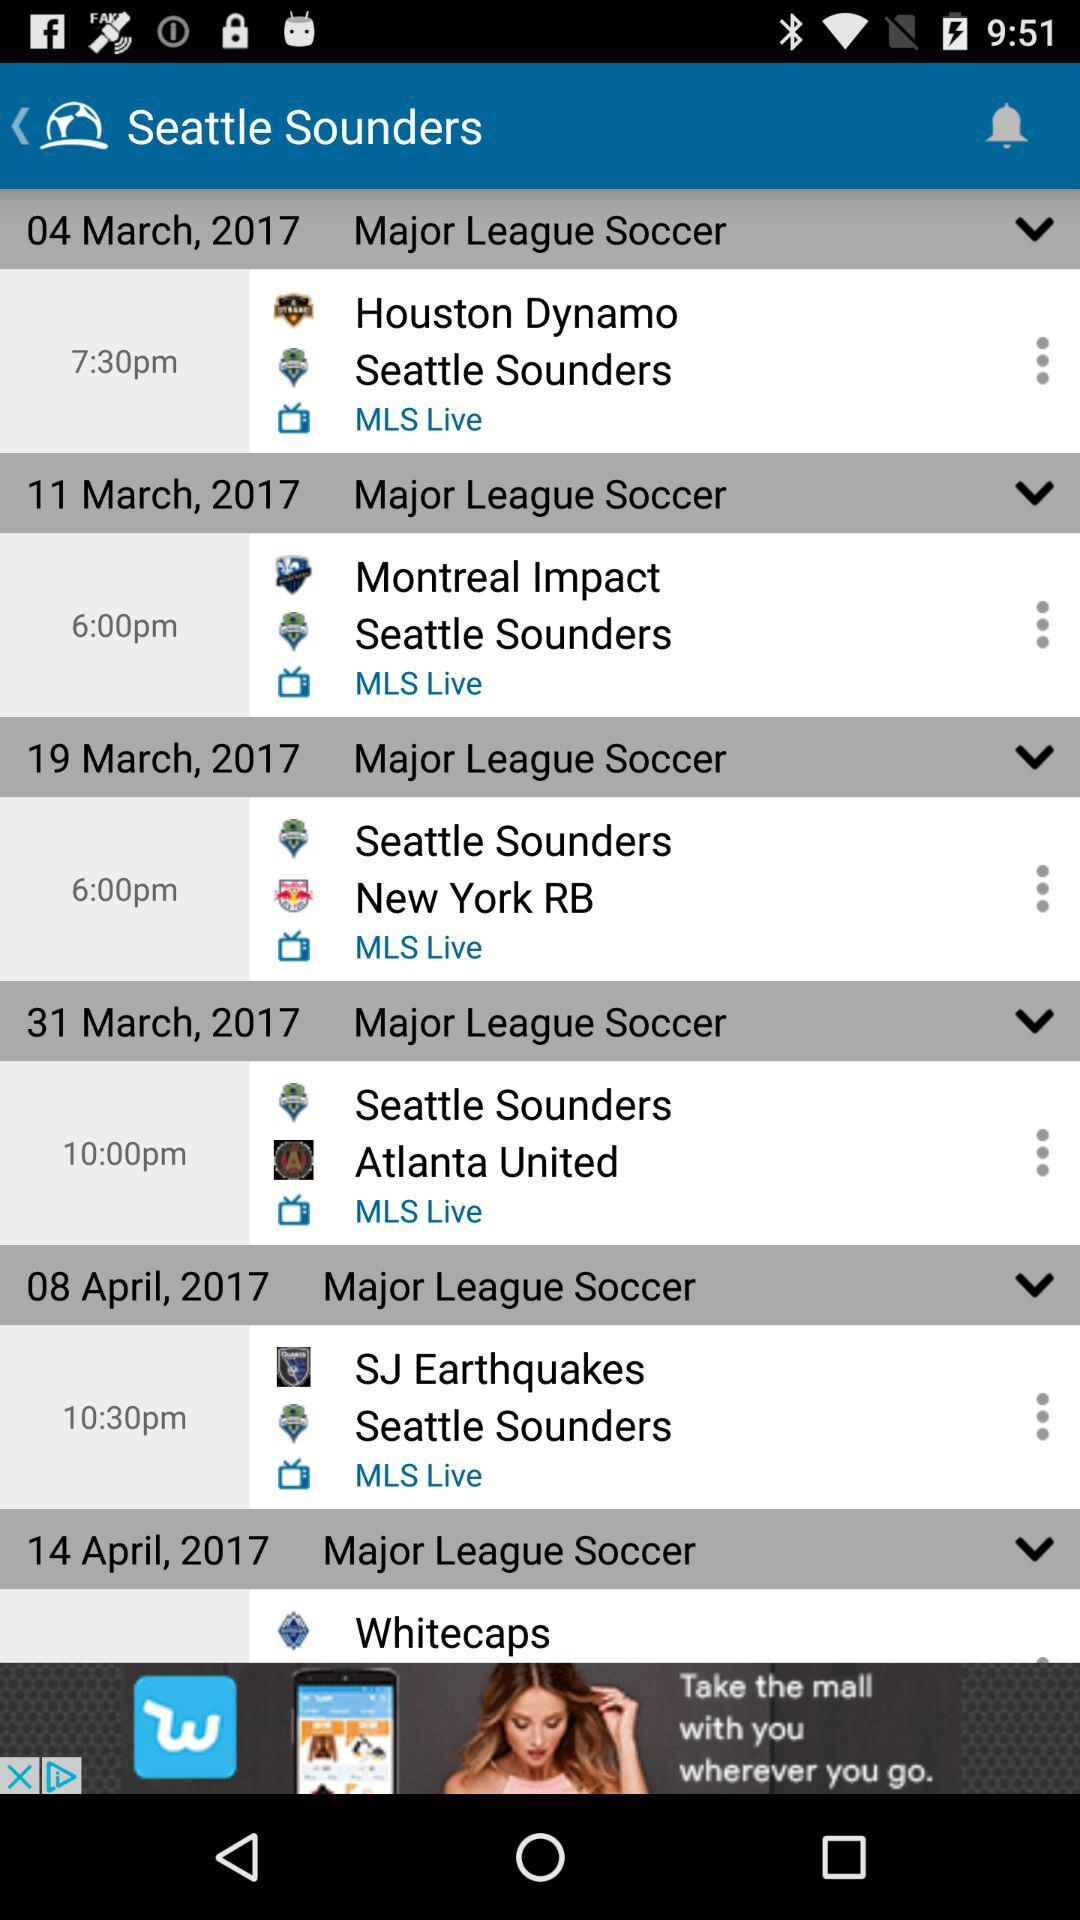List the teams from the "Major League Soccer". The list of teams from the "Major League Soccer" is "Houston Dynamo", "Seattle Sounders", "Montreal Impact", "New York RB", "Atlanta United", "SJ Earthquakes" and "Whitecaps". 